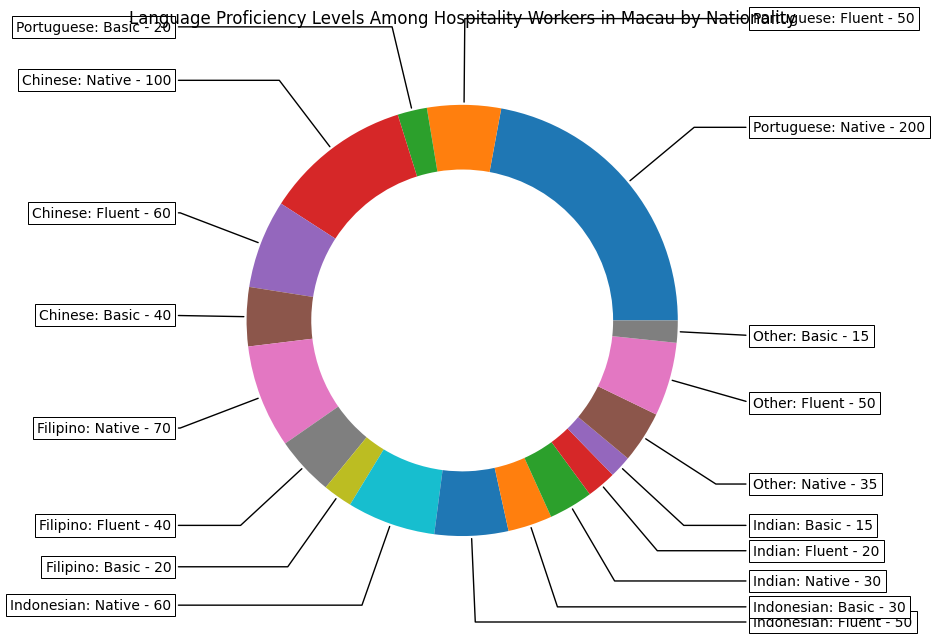What's the largest group by nationality and language proficiency? To find the largest group, we look at the sectors with the most workers by nationality and language proficiency. The "Chinese: Native" group stands out with 200 workers, which is more than any other group.
Answer: Chinese: Native Which nationality has the highest number of fluent workers? Compare the number of fluent workers across all nationalities: Portuguese (50), Chinese (50), Filipino (60), Indonesian (50), Indian (40), and Other (20). The highest number is within the Filipino group.
Answer: Filipino How many more native Chinese workers are there compared to native Portuguese workers? Native Chinese workers are 200, and native Portuguese workers are 35. Subtracting these two gives us 200 - 35 = 165.
Answer: 165 Which group has the smallest number of workers and what is that number? By examining each segment for the smallest number, we see that "Other: Basic" has 15 workers.
Answer: Other: Basic, 15 What is the total number of workers for the Indonesian nationality? Summing up all Indonesian workers across language proficiencies: 60 (Native) + 50 (Fluent) + 30 (Basic) = 140.
Answer: 140 Compare the number of basic language proficiency workers among the nationalities. Which group has the most and which has the least? Basic proficiency workers are: Portuguese (15), Chinese (20), Filipino (40), Indonesian (30), Indian (20), and Other (15). Most are Filipino (40) and least are Portuguese and Other (both 15).
Answer: Most: Filipino; Least: Portuguese and Other How does the total number of native language speakers compare to the total number of fluent speakers for all nationalities combined? Summing all native speakers: 35 (Portuguese) + 200 (Chinese) + 100 (Filipino) + 60 (Indonesian) + 70 (Indian) + 30 (Other) = 495. Summing all fluent speakers: 50 (Portuguese) + 50 (Chinese) + 60 (Filipino) + 50 (Indonesian) + 40 (Indian) + 20 (Other) = 270. The number of native speakers (495) far exceeds the number of fluent speakers (270).
Answer: Native: 495; Fluent: 270 What is the combined percentage of basic language proficiency workers among all nationalities? Total workers across all groups is 750. Total basic proficiency workers: 15 (Portuguese) + 20 (Chinese) + 40 (Filipino) + 30 (Indonesian) + 20 (Indian) + 15 (Other) = 140. The combined percentage is (140 / 750) * 100 ≈ 18.67%.
Answer: 18.67% What is the ratio of native Filipino workers to fluent Indonesian workers? Native Filipino workers are 100, and fluent Indonesian workers are 50. The ratio is 100:50, which simplifies to 2:1.
Answer: 2:1 